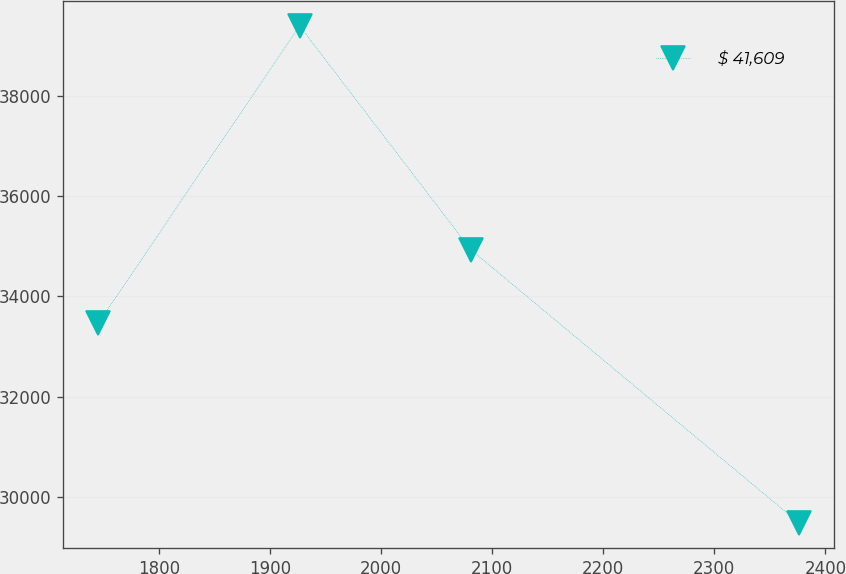Convert chart. <chart><loc_0><loc_0><loc_500><loc_500><line_chart><ecel><fcel>$ 41,609<nl><fcel>1745.39<fcel>33471.4<nl><fcel>1926.5<fcel>39388.1<nl><fcel>2080.66<fcel>34931.5<nl><fcel>2376.55<fcel>29479.8<nl></chart> 